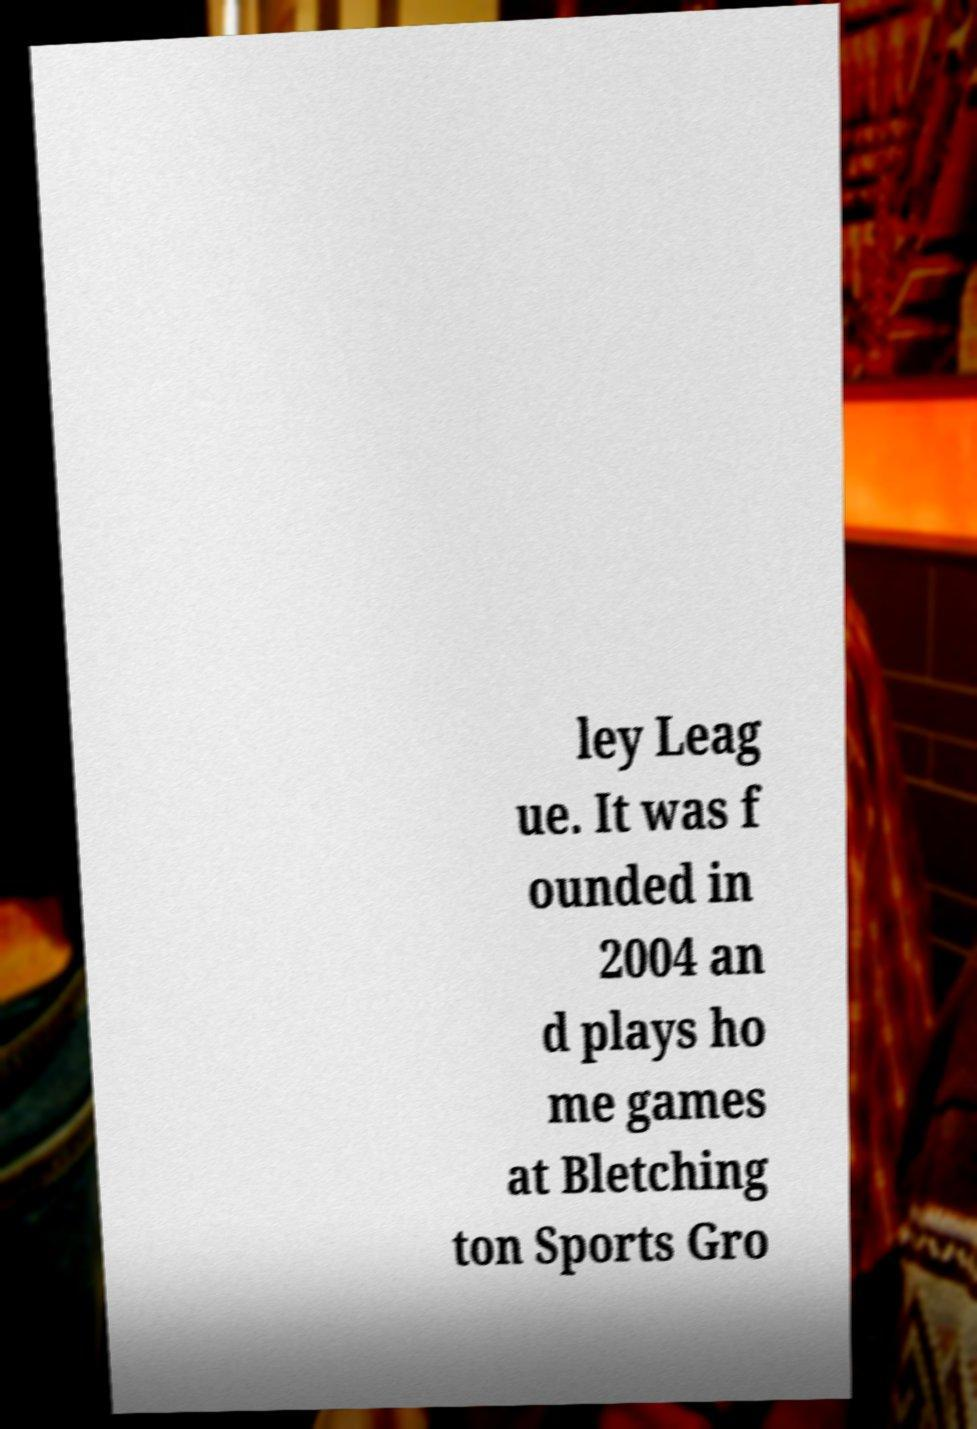Please read and relay the text visible in this image. What does it say? ley Leag ue. It was f ounded in 2004 an d plays ho me games at Bletching ton Sports Gro 